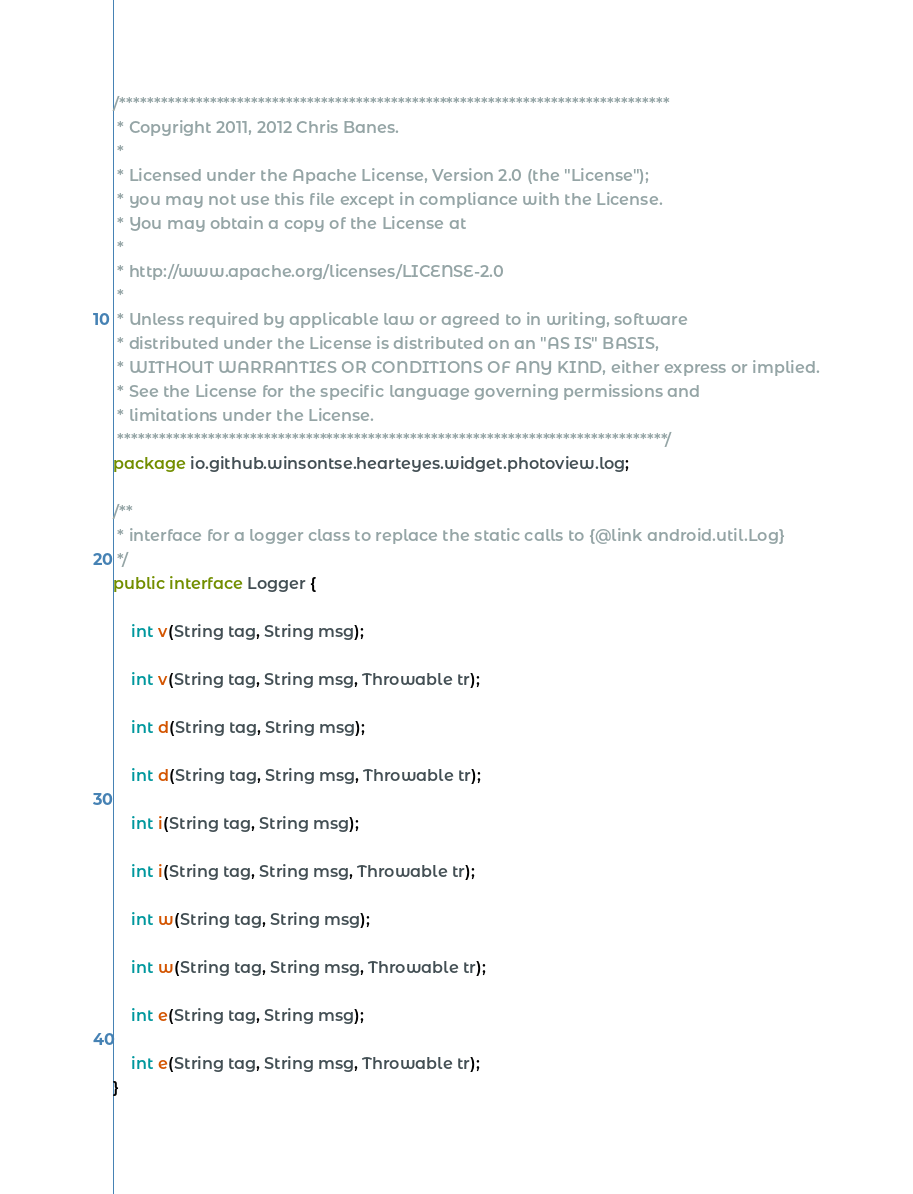<code> <loc_0><loc_0><loc_500><loc_500><_Java_>/*******************************************************************************
 * Copyright 2011, 2012 Chris Banes.
 *
 * Licensed under the Apache License, Version 2.0 (the "License");
 * you may not use this file except in compliance with the License.
 * You may obtain a copy of the License at
 *
 * http://www.apache.org/licenses/LICENSE-2.0
 *
 * Unless required by applicable law or agreed to in writing, software
 * distributed under the License is distributed on an "AS IS" BASIS,
 * WITHOUT WARRANTIES OR CONDITIONS OF ANY KIND, either express or implied.
 * See the License for the specific language governing permissions and
 * limitations under the License.
 *******************************************************************************/
package io.github.winsontse.hearteyes.widget.photoview.log;

/**
 * interface for a logger class to replace the static calls to {@link android.util.Log}
 */
public interface Logger {

    int v(String tag, String msg);

    int v(String tag, String msg, Throwable tr);

    int d(String tag, String msg);

    int d(String tag, String msg, Throwable tr);

    int i(String tag, String msg);

    int i(String tag, String msg, Throwable tr);

    int w(String tag, String msg);

    int w(String tag, String msg, Throwable tr);

    int e(String tag, String msg);

    int e(String tag, String msg, Throwable tr);
}
</code> 